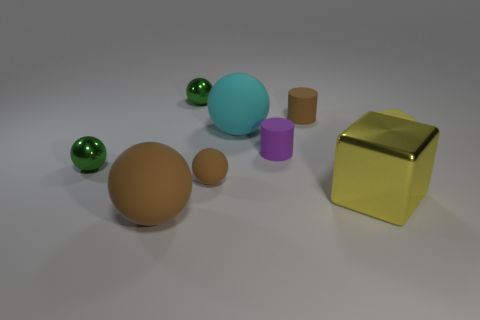Subtract all tiny brown balls. How many balls are left? 4 Subtract all cyan cylinders. How many brown balls are left? 2 Subtract all green spheres. How many spheres are left? 3 Add 1 cyan matte balls. How many objects exist? 10 Subtract 2 spheres. How many spheres are left? 3 Subtract all balls. How many objects are left? 4 Subtract all gray spheres. Subtract all gray cylinders. How many spheres are left? 5 Subtract 1 brown cylinders. How many objects are left? 8 Subtract all small gray rubber cubes. Subtract all large cyan rubber things. How many objects are left? 8 Add 7 tiny purple objects. How many tiny purple objects are left? 8 